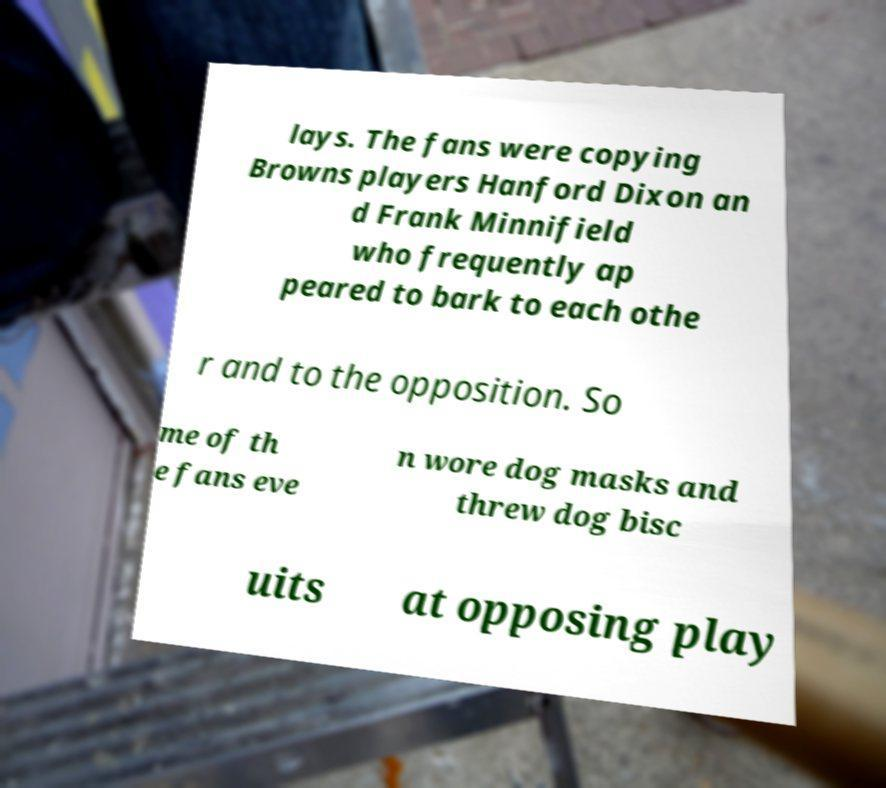Please identify and transcribe the text found in this image. lays. The fans were copying Browns players Hanford Dixon an d Frank Minnifield who frequently ap peared to bark to each othe r and to the opposition. So me of th e fans eve n wore dog masks and threw dog bisc uits at opposing play 